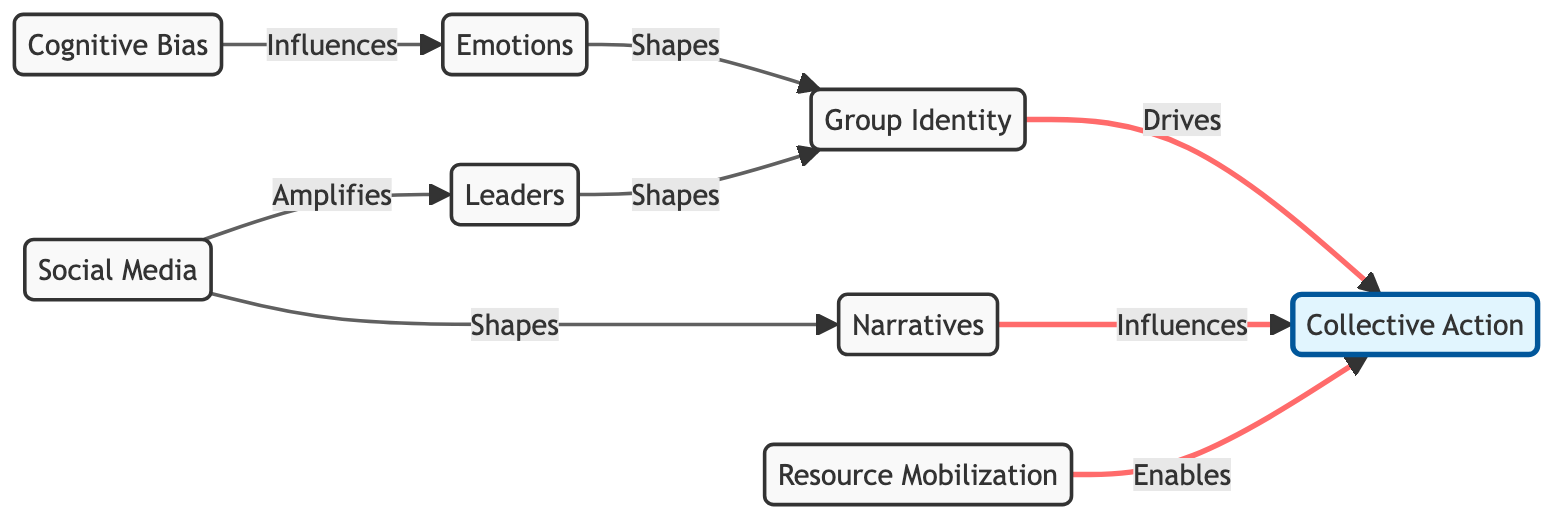What are the nodes represented in the diagram? The nodes in the diagram include Cognitive Bias, Emotions, Group Identity, Social Media, Collective Action, Narratives, Leaders, and Resource Mobilization.
Answer: Cognitive Bias, Emotions, Group Identity, Social Media, Collective Action, Narratives, Leaders, Resource Mobilization How many edges are in the diagram? Counting the connections between the nodes, the diagram has a total of 8 edges connecting various nodes.
Answer: 8 What influences Emotions in the diagram? The diagram shows that Cognitive Bias influences Emotions, as indicated by the directed edge from Cognitive Bias to Emotions.
Answer: Cognitive Bias Which node is driven by Group Identity? The directed graph illustrates that Collective Action is the result driven by Group Identity, as depicted by the arrow from Group Identity to Collective Action.
Answer: Collective Action What enables Collective Action in the diagram? Resource Mobilization enables Collective Action, as shown by the direct connection from Resource Mobilization to Collective Action in the diagram.
Answer: Resource Mobilization How does Social Media relate to Leaders? Social Media amplifies Leaders, as indicated by the directed edge leading from Social Media to Leaders in the graph.
Answer: Amplifies What shapes Group Identity according to the diagram? Emotions shape Group Identity, based on the flow from Emotions to Group Identity shown in the directed graph.
Answer: Emotions Which two nodes have a narrative connection influencing Collective Action? The nodes related through narratives influencing Collective Action are Narratives and Social Media, where Social Media shapes Narratives and then Narratives influences Collective Action.
Answer: Social Media, Narratives What is the main effect of Leaders on Group Identity? Leaders shape Group Identity, as represented in the diagram by the directional edge connecting Leaders to Group Identity.
Answer: Shapes 